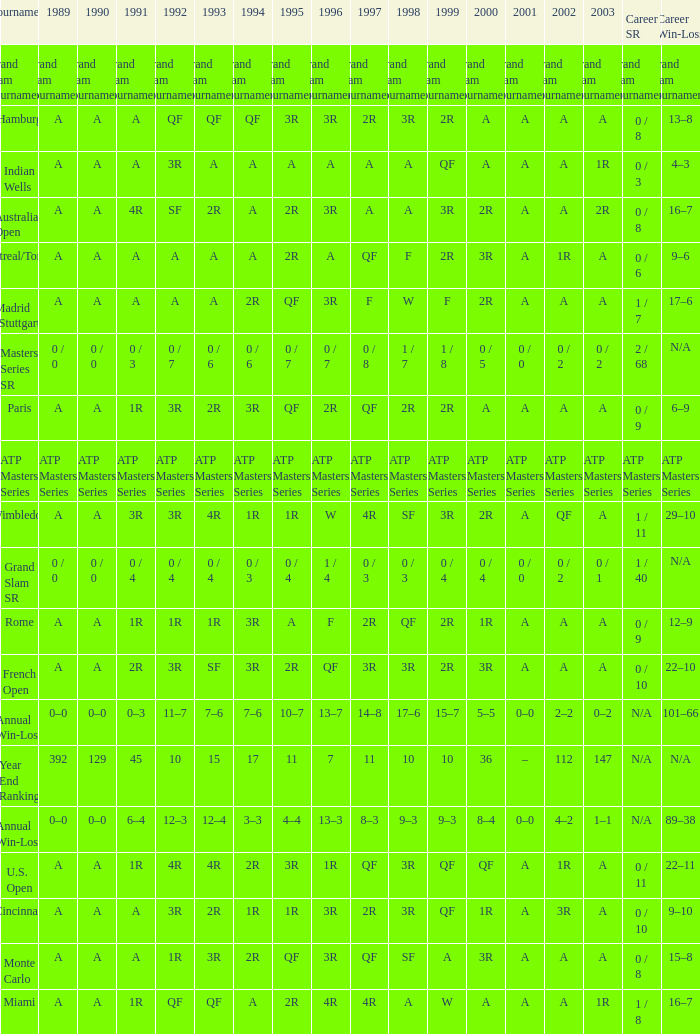What was the value in 1989 with QF in 1997 and A in 1993? A. 